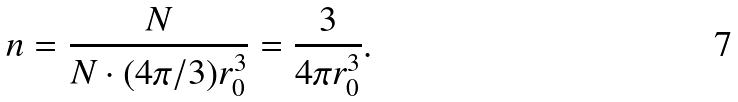<formula> <loc_0><loc_0><loc_500><loc_500>n = \frac { N } { N \cdot ( 4 \pi / 3 ) r _ { 0 } ^ { 3 } } = \frac { 3 } { 4 \pi r _ { 0 } ^ { 3 } } .</formula> 